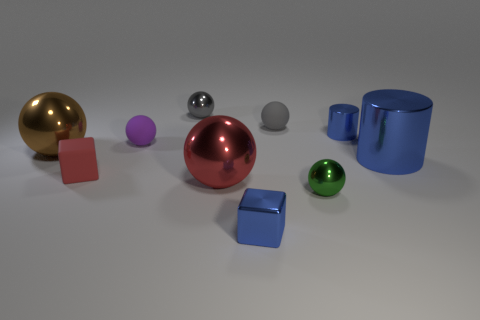Subtract all small metal balls. How many balls are left? 4 Subtract all brown balls. How many balls are left? 5 Subtract all balls. How many objects are left? 4 Subtract 2 balls. How many balls are left? 4 Subtract all purple cubes. How many yellow spheres are left? 0 Subtract all large red matte objects. Subtract all metal things. How many objects are left? 3 Add 6 tiny blue cubes. How many tiny blue cubes are left? 7 Add 2 large blue metallic cylinders. How many large blue metallic cylinders exist? 3 Subtract 0 purple blocks. How many objects are left? 10 Subtract all blue blocks. Subtract all red cylinders. How many blocks are left? 1 